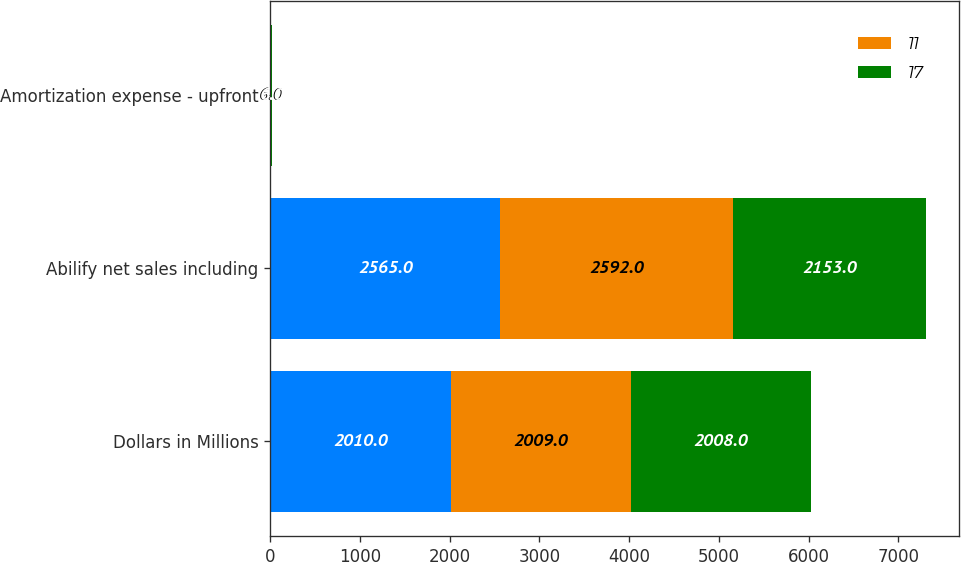<chart> <loc_0><loc_0><loc_500><loc_500><stacked_bar_chart><ecel><fcel>Dollars in Millions<fcel>Abilify net sales including<fcel>Amortization expense - upfront<nl><fcel>nan<fcel>2010<fcel>2565<fcel>6<nl><fcel>11<fcel>2009<fcel>2592<fcel>6<nl><fcel>17<fcel>2008<fcel>2153<fcel>6<nl></chart> 